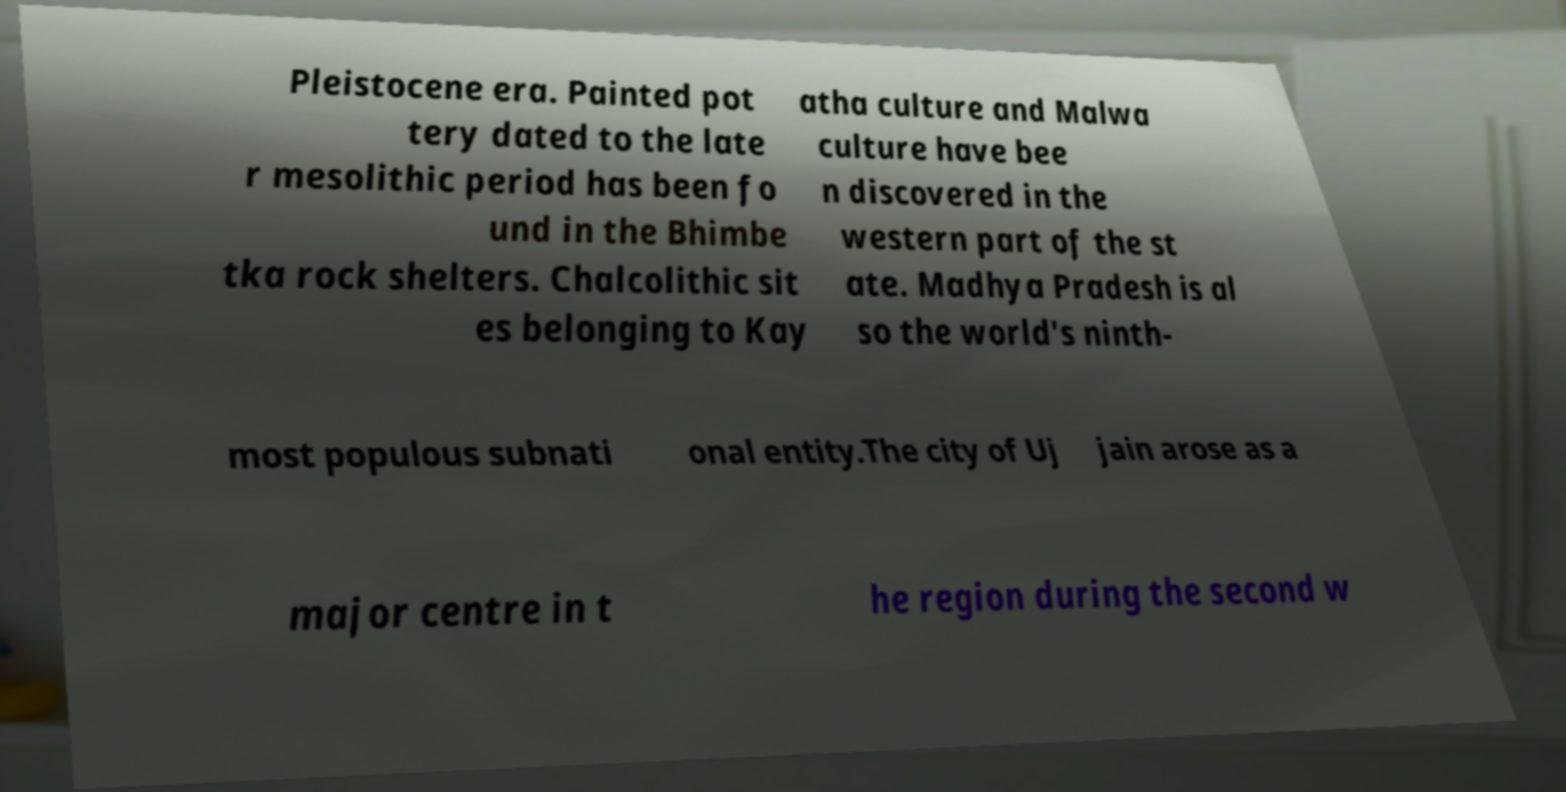Can you read and provide the text displayed in the image?This photo seems to have some interesting text. Can you extract and type it out for me? Pleistocene era. Painted pot tery dated to the late r mesolithic period has been fo und in the Bhimbe tka rock shelters. Chalcolithic sit es belonging to Kay atha culture and Malwa culture have bee n discovered in the western part of the st ate. Madhya Pradesh is al so the world's ninth- most populous subnati onal entity.The city of Uj jain arose as a major centre in t he region during the second w 